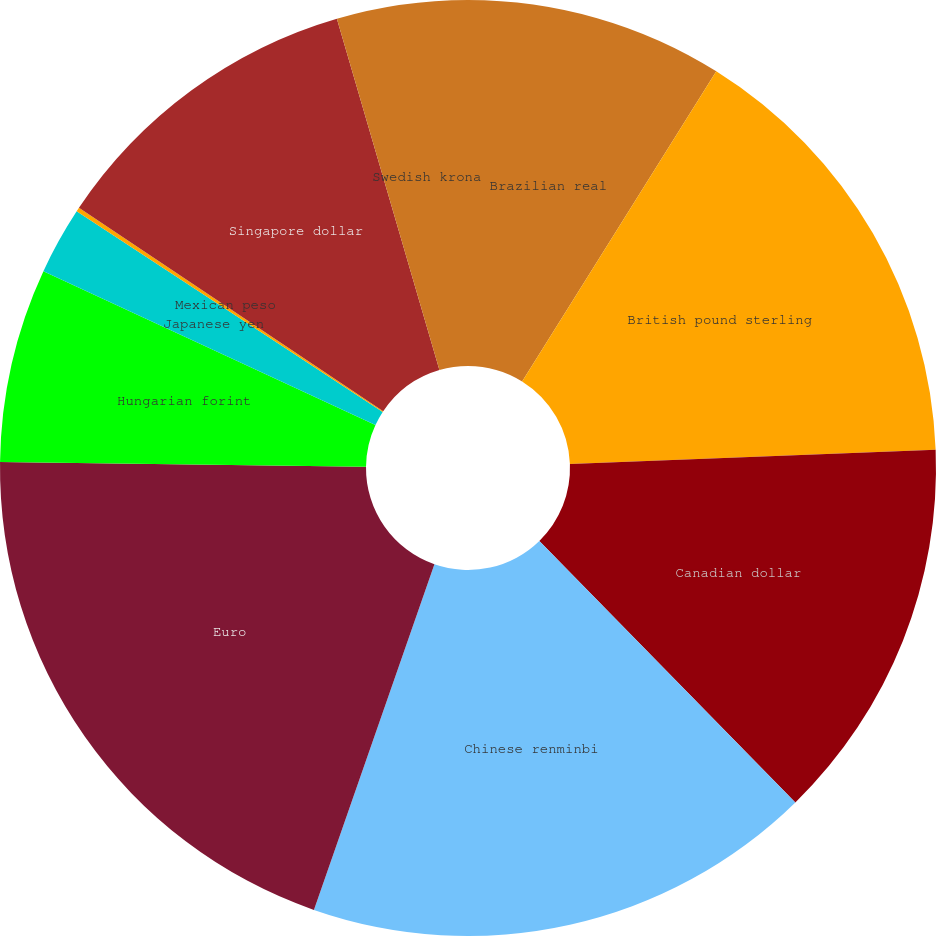<chart> <loc_0><loc_0><loc_500><loc_500><pie_chart><fcel>Brazilian real<fcel>British pound sterling<fcel>Canadian dollar<fcel>Chinese renminbi<fcel>Euro<fcel>Hungarian forint<fcel>Japanese yen<fcel>Mexican peso<fcel>Singapore dollar<fcel>Swedish krona<nl><fcel>8.9%<fcel>15.48%<fcel>13.29%<fcel>17.67%<fcel>19.86%<fcel>6.71%<fcel>2.33%<fcel>0.14%<fcel>11.1%<fcel>4.52%<nl></chart> 